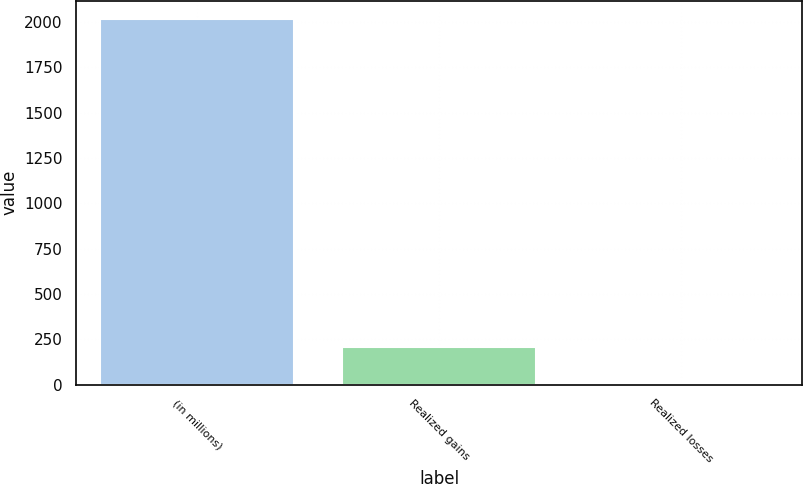Convert chart. <chart><loc_0><loc_0><loc_500><loc_500><bar_chart><fcel>(in millions)<fcel>Realized gains<fcel>Realized losses<nl><fcel>2016<fcel>209.7<fcel>9<nl></chart> 